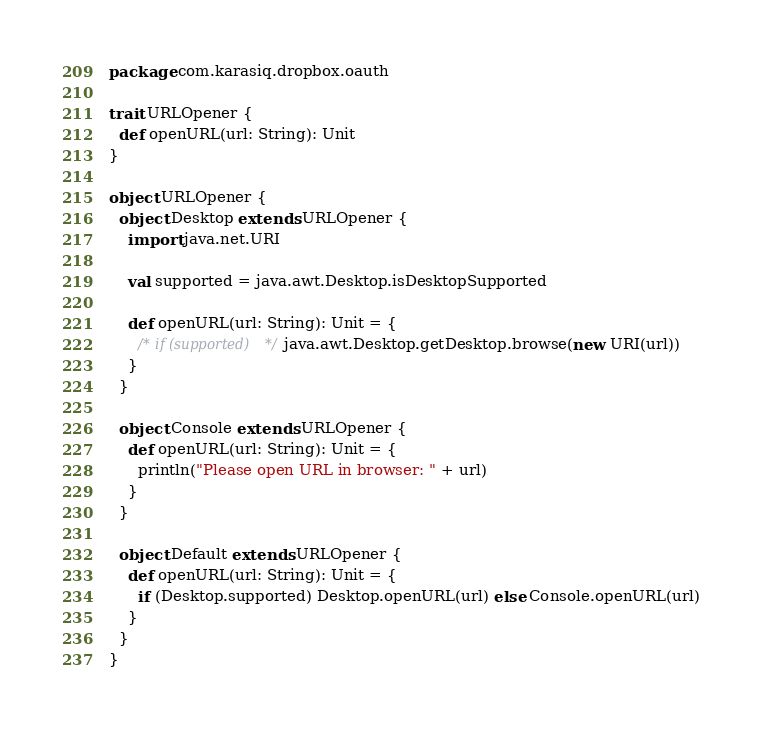<code> <loc_0><loc_0><loc_500><loc_500><_Scala_>package com.karasiq.dropbox.oauth

trait URLOpener {
  def openURL(url: String): Unit
}

object URLOpener {
  object Desktop extends URLOpener {
    import java.net.URI

    val supported = java.awt.Desktop.isDesktopSupported

    def openURL(url: String): Unit = {
      /* if (supported) */ java.awt.Desktop.getDesktop.browse(new URI(url))
    }
  }

  object Console extends URLOpener {
    def openURL(url: String): Unit = {
      println("Please open URL in browser: " + url)
    }
  }

  object Default extends URLOpener {
    def openURL(url: String): Unit = {
      if (Desktop.supported) Desktop.openURL(url) else Console.openURL(url)
    }
  }
}
</code> 